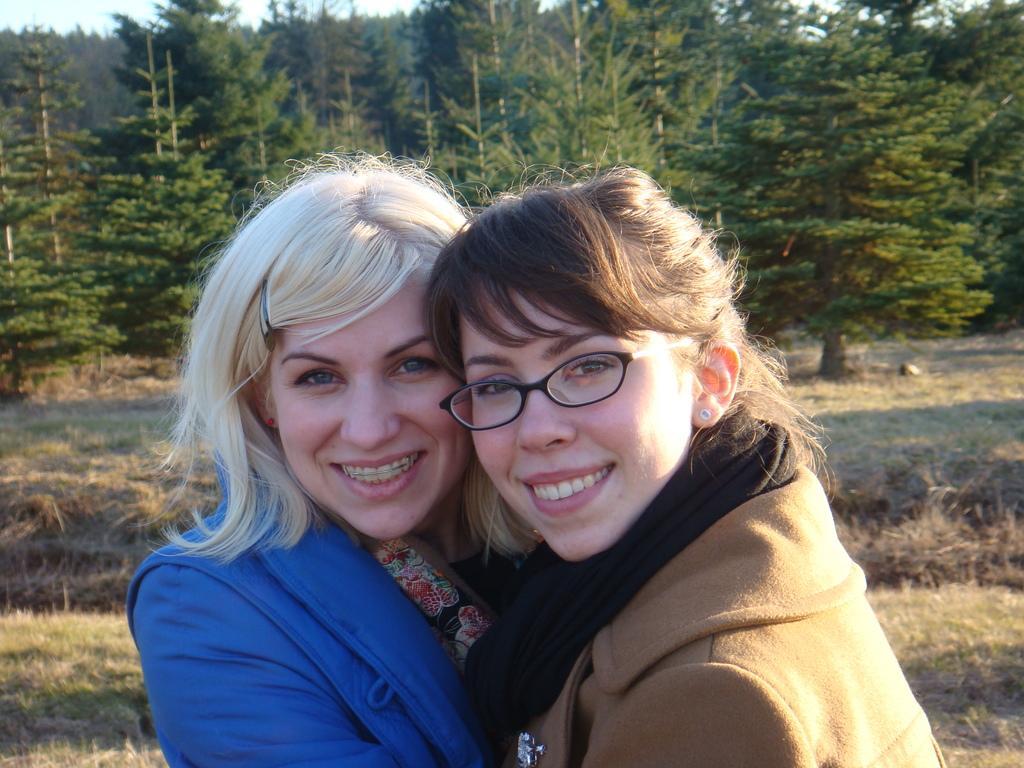In one or two sentences, can you explain what this image depicts? In this picture we can see two women are standing on the grass, behind we can see some trees. 